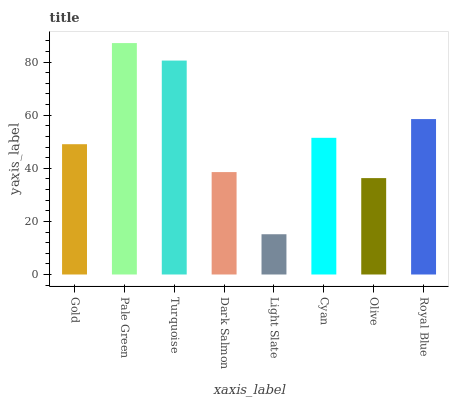Is Light Slate the minimum?
Answer yes or no. Yes. Is Pale Green the maximum?
Answer yes or no. Yes. Is Turquoise the minimum?
Answer yes or no. No. Is Turquoise the maximum?
Answer yes or no. No. Is Pale Green greater than Turquoise?
Answer yes or no. Yes. Is Turquoise less than Pale Green?
Answer yes or no. Yes. Is Turquoise greater than Pale Green?
Answer yes or no. No. Is Pale Green less than Turquoise?
Answer yes or no. No. Is Cyan the high median?
Answer yes or no. Yes. Is Gold the low median?
Answer yes or no. Yes. Is Royal Blue the high median?
Answer yes or no. No. Is Royal Blue the low median?
Answer yes or no. No. 